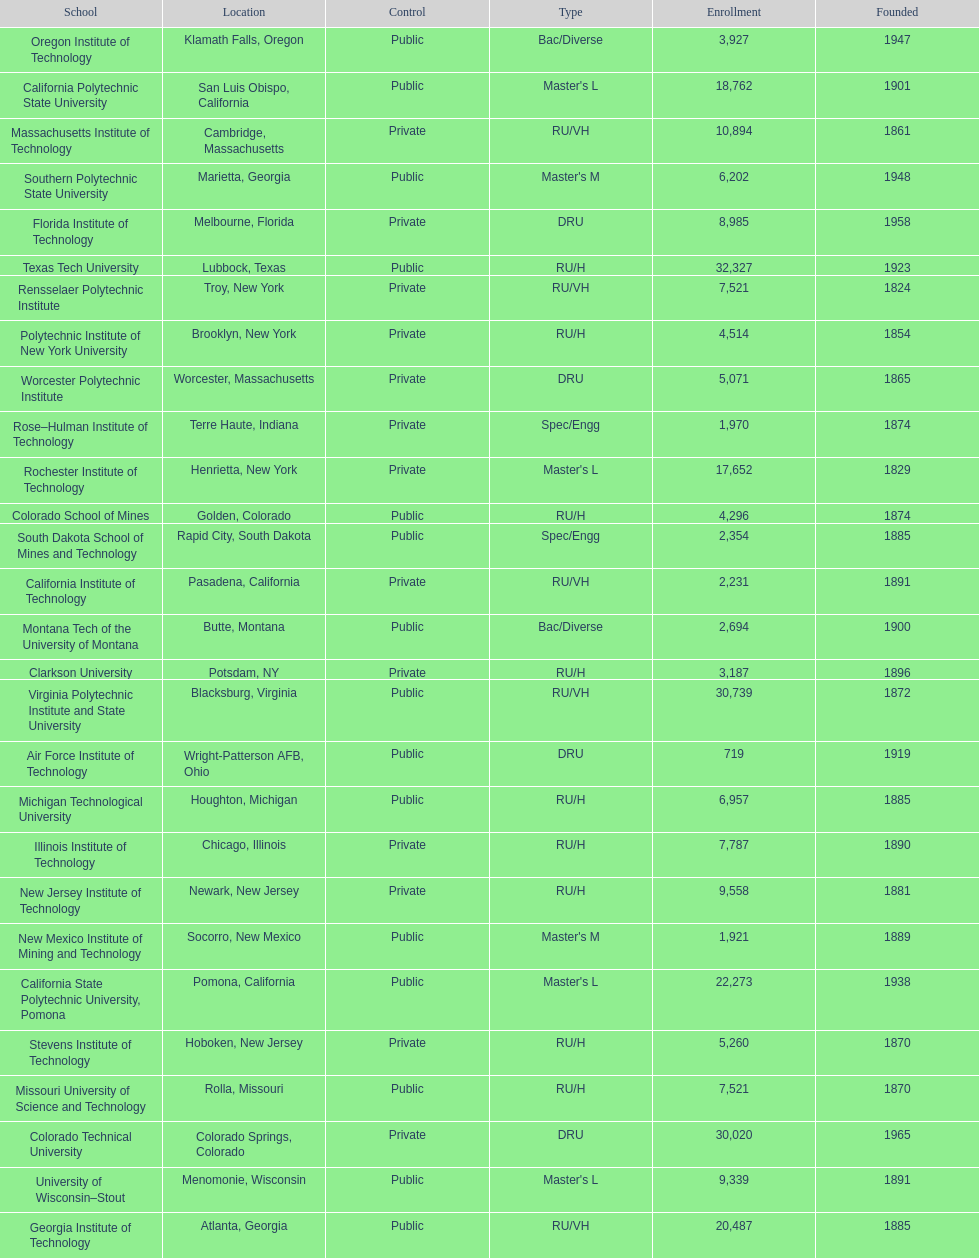What is the difference in enrollment between the top 2 schools listed in the table? 1512. 